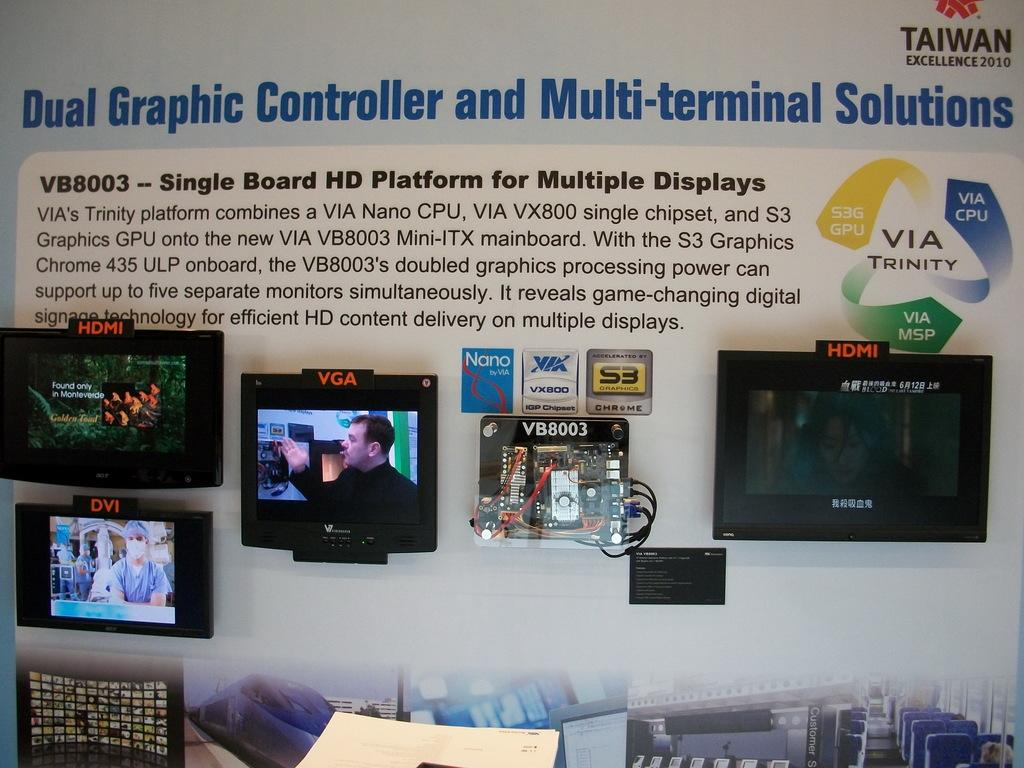Provide a one-sentence caption for the provided image. A display with information about dual graphic controllers has several monitors glued to it. 